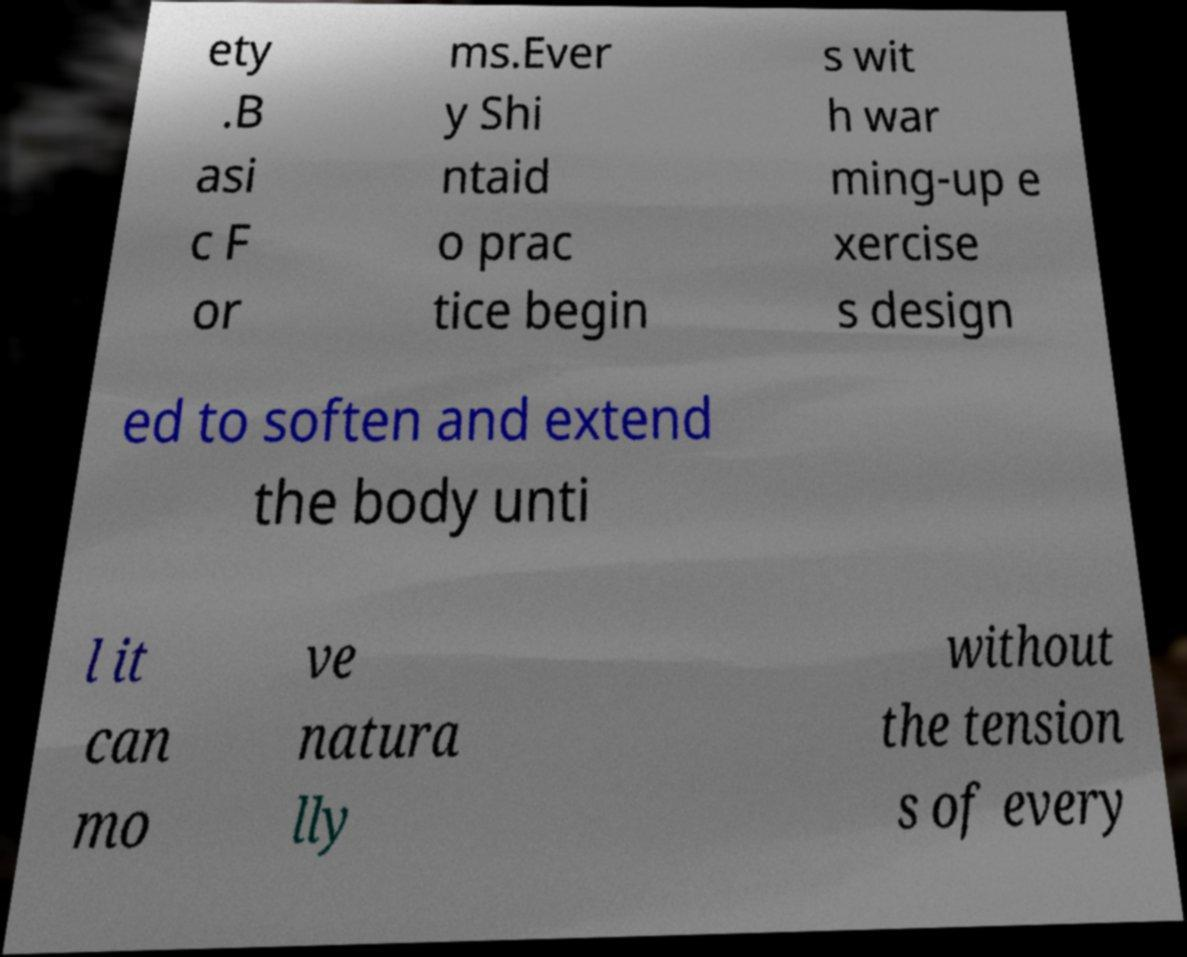Please read and relay the text visible in this image. What does it say? ety .B asi c F or ms.Ever y Shi ntaid o prac tice begin s wit h war ming-up e xercise s design ed to soften and extend the body unti l it can mo ve natura lly without the tension s of every 